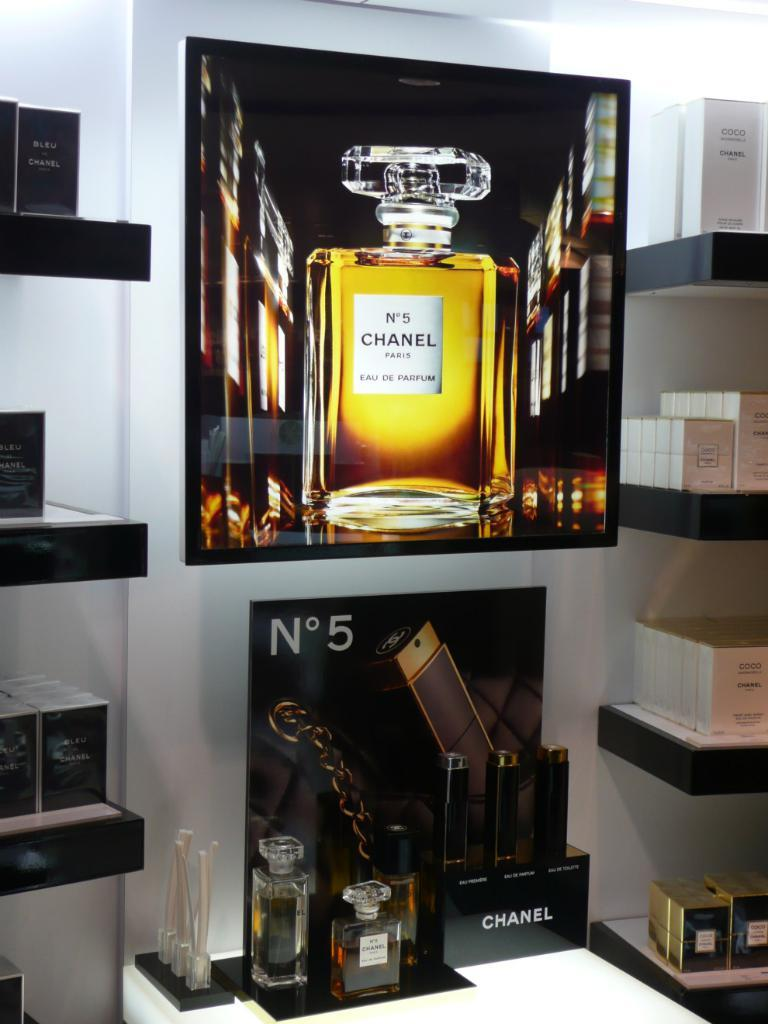<image>
Create a compact narrative representing the image presented. Poster for the perfume Chanel No5 on display at a store. 